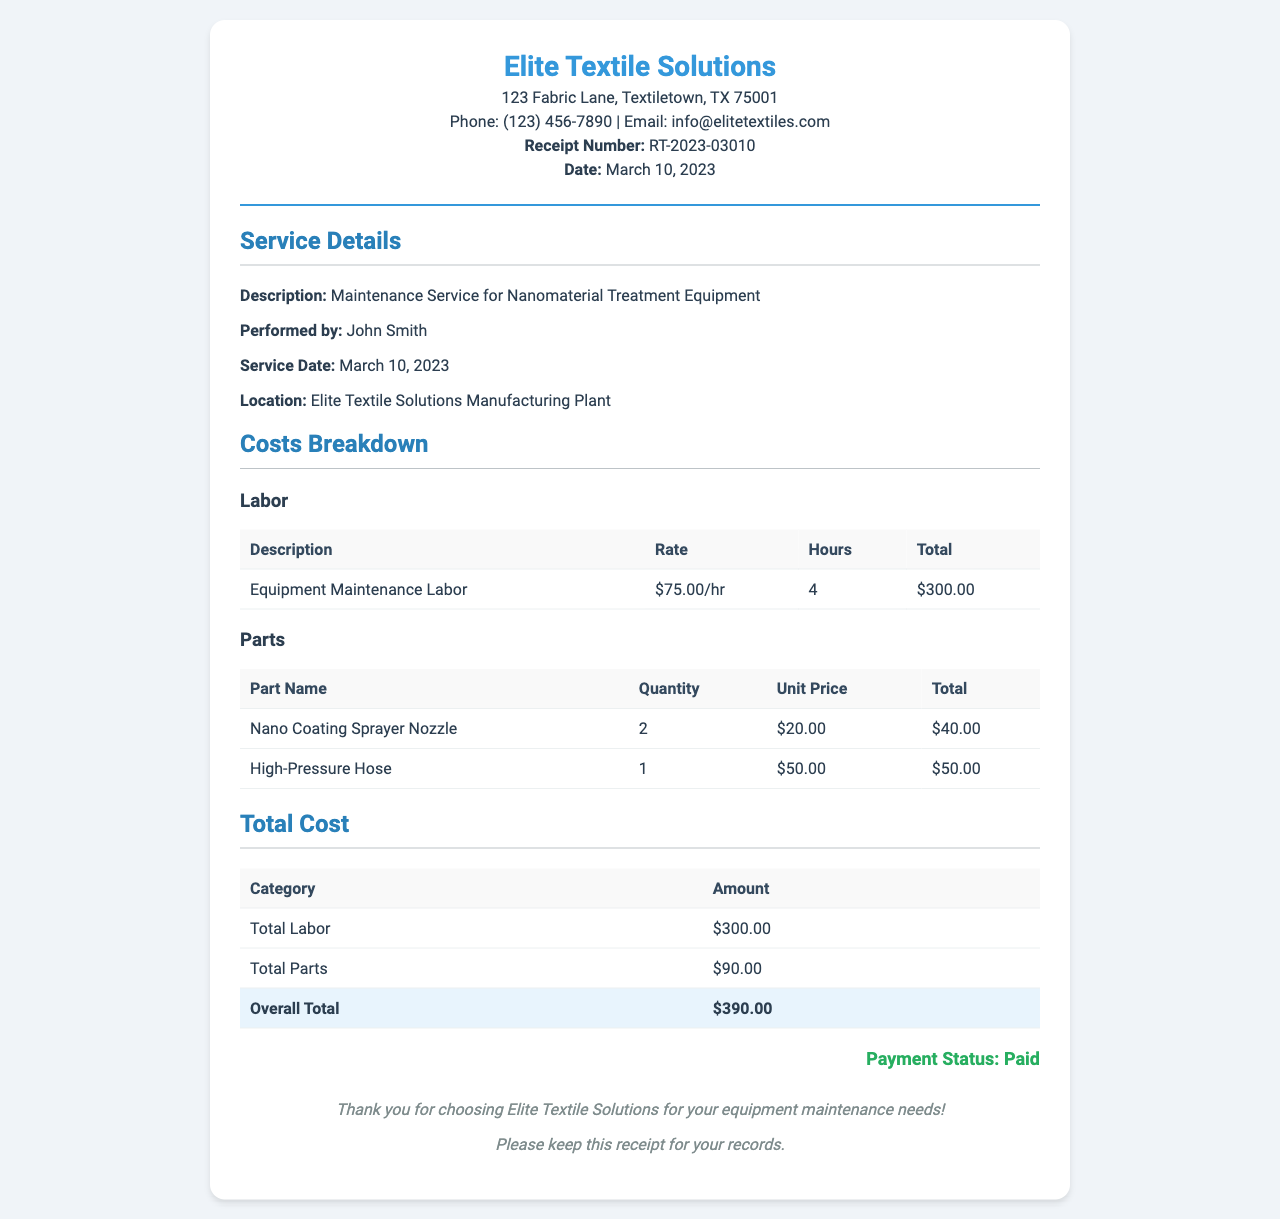What is the receipt number? The receipt number is specified in the document header as RT-2023-03010.
Answer: RT-2023-03010 Who performed the maintenance service? The document indicates that John Smith was the individual who performed the service.
Answer: John Smith What was the total cost of labor? The total cost of labor is specified in the costs breakdown section as $300.00.
Answer: $300.00 How many hours of labor were charged? The document shows that 4 hours of labor were charged for the maintenance service.
Answer: 4 What is the total cost of parts? The total cost of parts is summarized in the total cost section, which indicates $90.00.
Answer: $90.00 What is the overall total amount billed? The overall total is detailed in the total cost section as $390.00.
Answer: $390.00 What is the phone number listed in the document? The phone number provided in the header of the document is (123) 456-7890.
Answer: (123) 456-7890 What type of service was performed? The document specifies that the service performed was maintenance for nanomaterial treatment equipment.
Answer: Maintenance Service for Nanomaterial Treatment Equipment What is the payment status? The document states that the payment status is paid.
Answer: Paid 